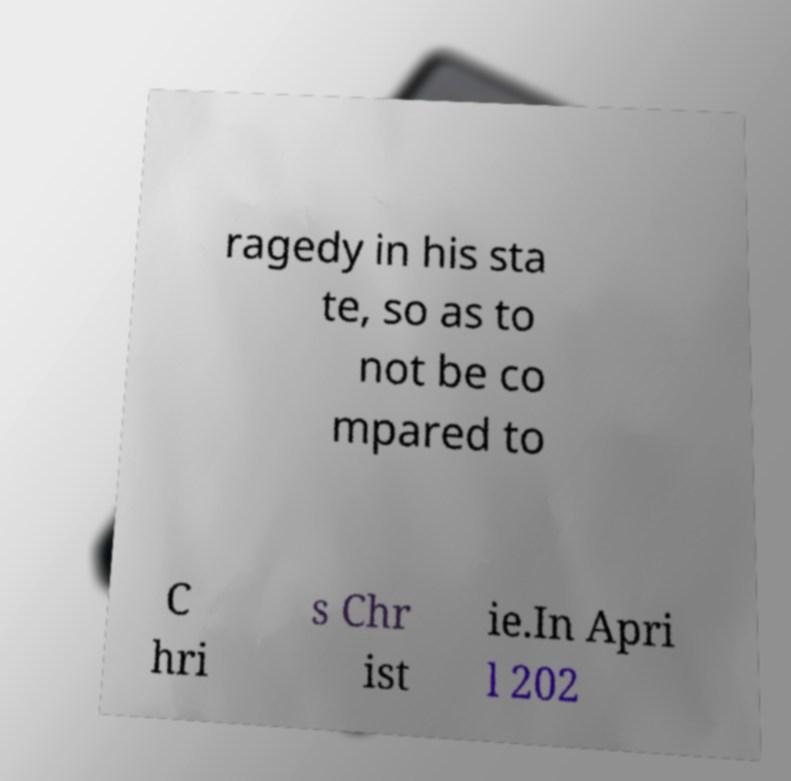Could you extract and type out the text from this image? ragedy in his sta te, so as to not be co mpared to C hri s Chr ist ie.In Apri l 202 